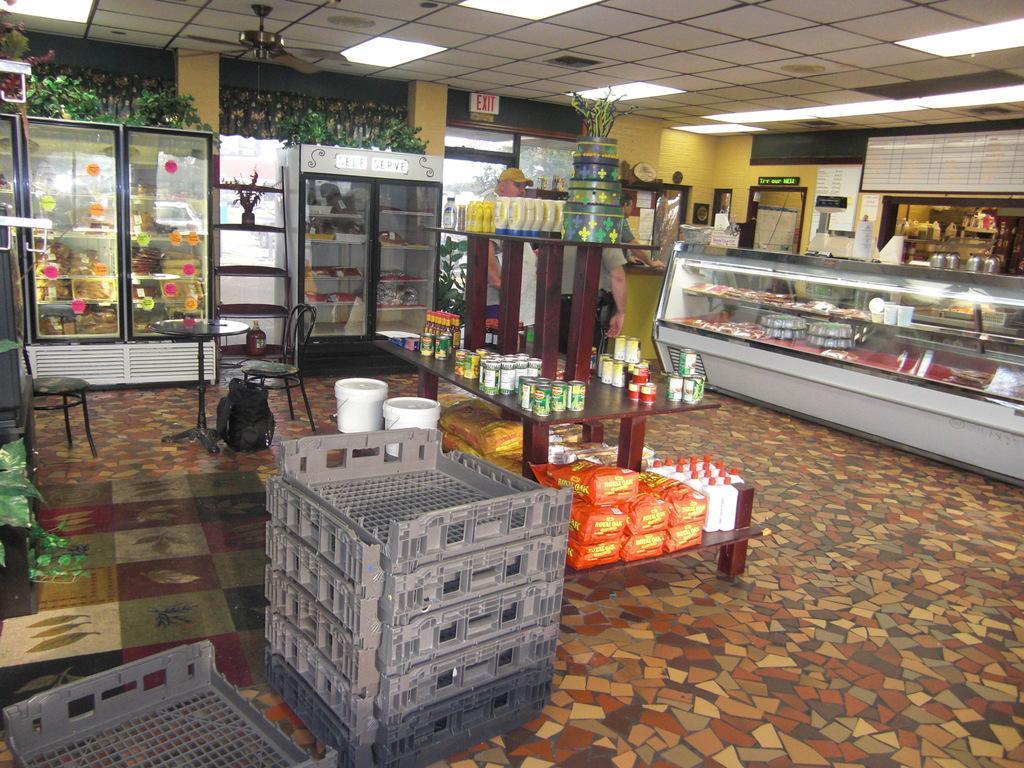Can you describe this image briefly? In this image in the front there are crates. In the center there is a table and on the table there are tin cans, there are packets, bottles, there is a plant, there are buckets which are white in colour, there are empty chairs, there is a table and on the table there are objects which are pink and blue in colour and under the table there is a bag which is black in colour. In the background there are refrigerators. On the right side there is a table and there are persons, there are boards with some text written on it and there is a door, there is a window. In the background there is a window and on the top of the refrigerator there are plants, there is a fan on the ceiling. On the left side there are leaves which are visible. 